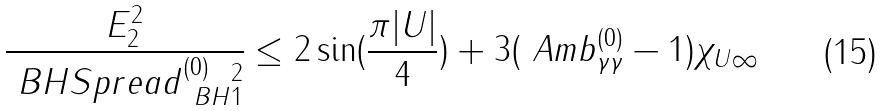<formula> <loc_0><loc_0><loc_500><loc_500>\frac { E _ { 2 } ^ { 2 } } { \| \ B H S p r e a d ^ { ( 0 ) } _ { \ B H } \| ^ { 2 } _ { 1 } } \leq 2 \sin ( \frac { \pi | U | } { 4 } ) + 3 \| ( \ A m b ^ { ( 0 ) } _ { \gamma \gamma } - 1 ) \chi _ { U } \| _ { \infty }</formula> 